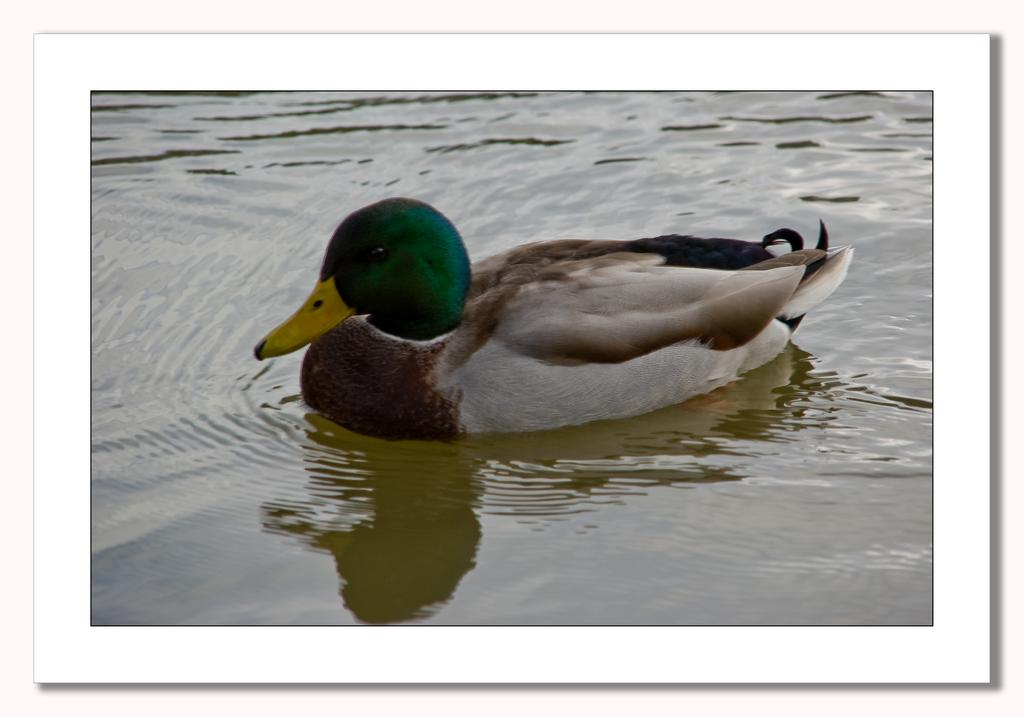What animal is present in the image? There is a duck in the image. Where is the duck located in the image? The duck is in water. What color is the duck's beak? The duck has a yellow-colored beak. What type of pies can be seen in the image? There are no pies present in the image. Can you tell me how many squirrels are visible in the image? There are no squirrels visible in the image. 